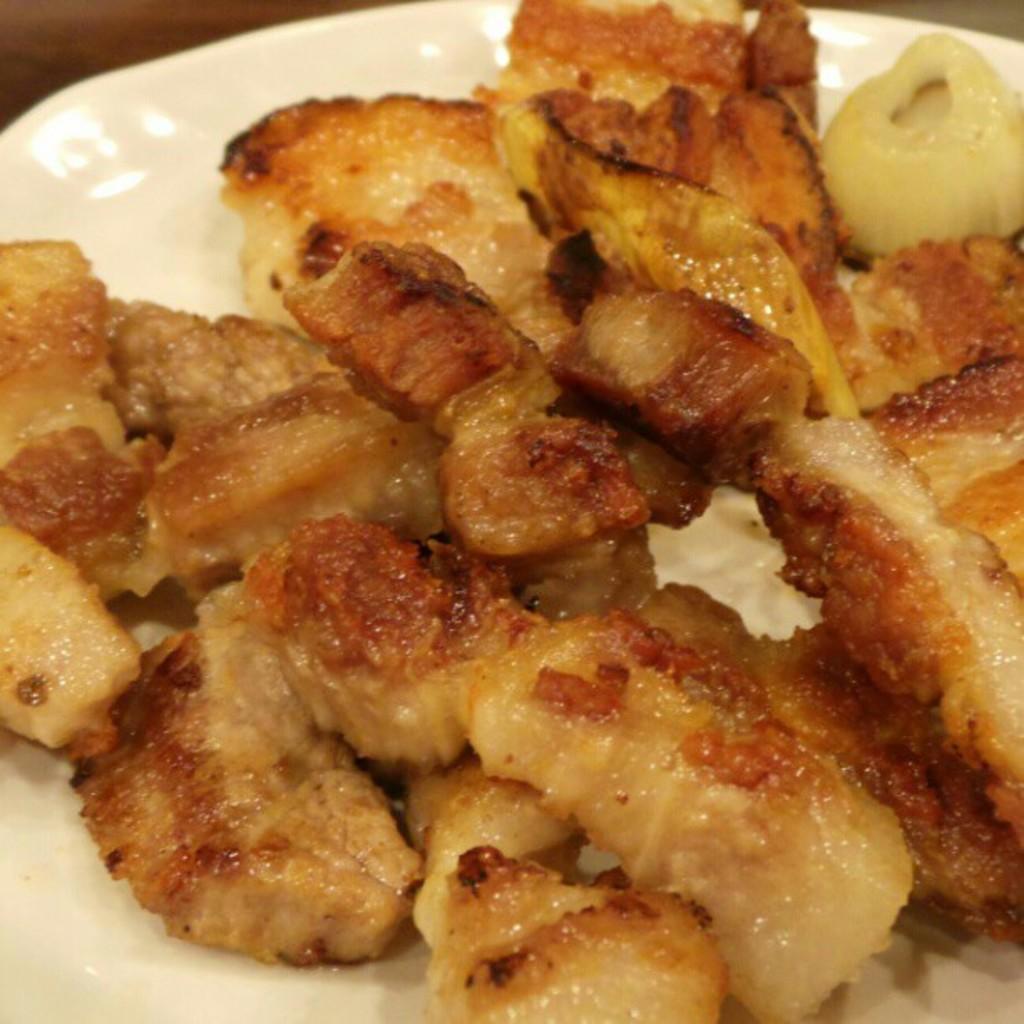Could you give a brief overview of what you see in this image? Here we can see a food item in a plate on a platform. 